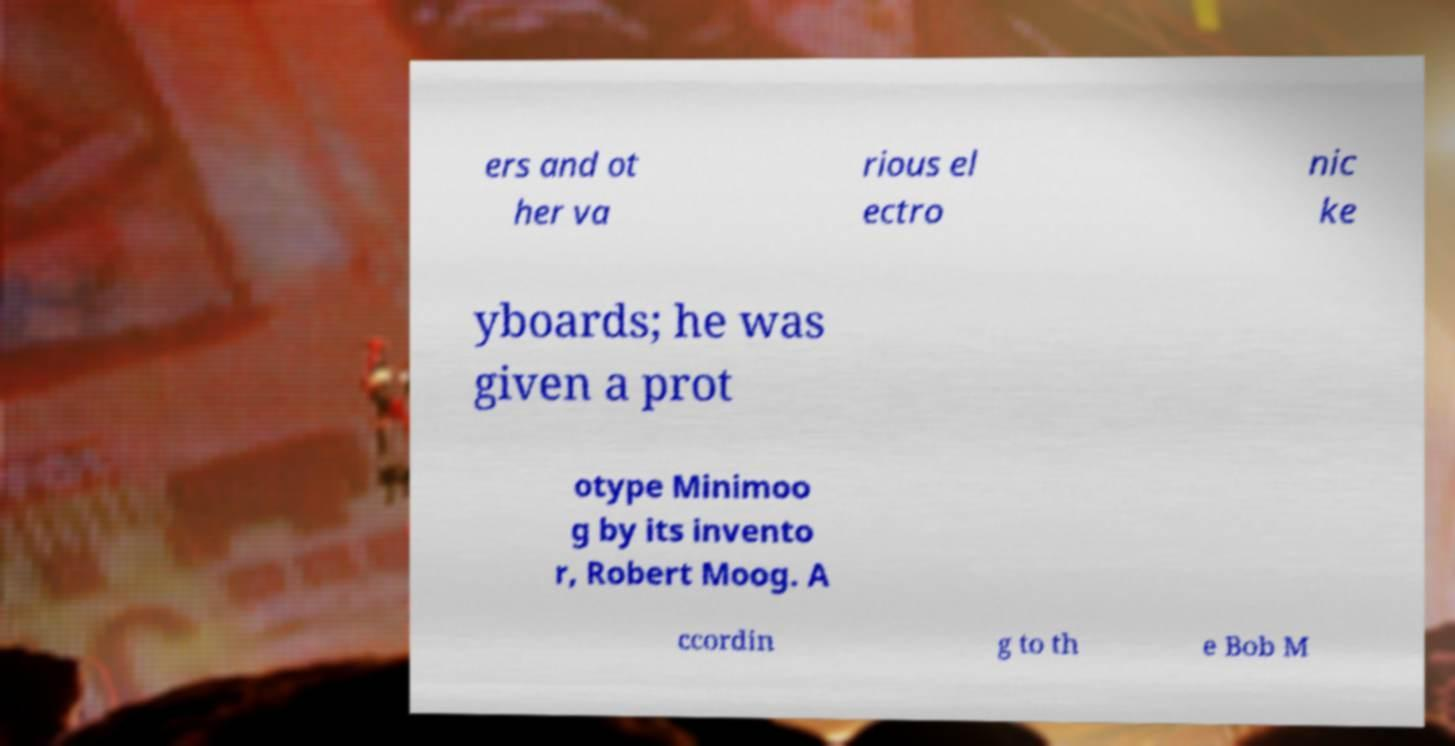For documentation purposes, I need the text within this image transcribed. Could you provide that? ers and ot her va rious el ectro nic ke yboards; he was given a prot otype Minimoo g by its invento r, Robert Moog. A ccordin g to th e Bob M 